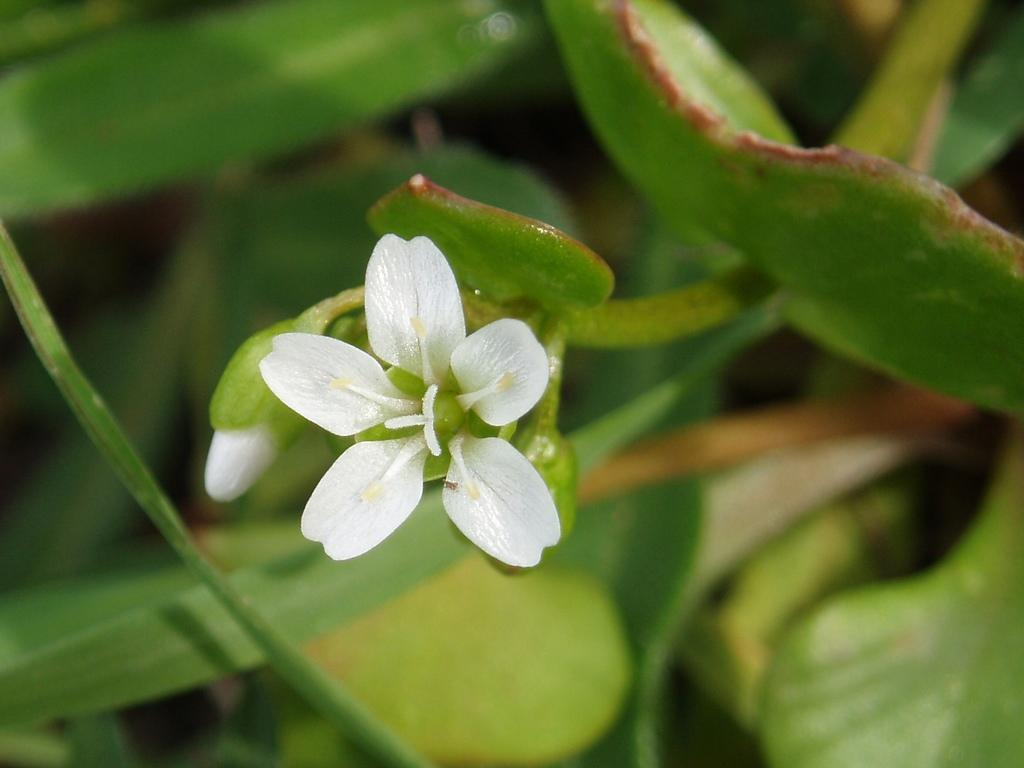What type of plant can be seen in the image? There is a flower in the image. Can you describe the stage of growth of the plant in the image? There is a bud on the plant in the image. What type of attention is the flower receiving in the image? The image does not provide information about the flower receiving any attention. What scientific discoveries can be made from studying the flower in the image? The image does not provide information about any scientific discoveries related to the flower. 